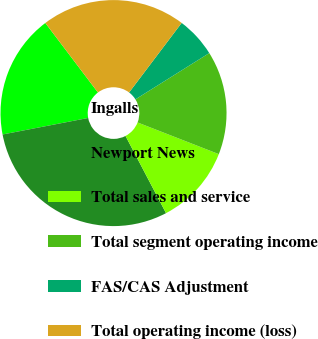Convert chart. <chart><loc_0><loc_0><loc_500><loc_500><pie_chart><fcel>Ingalls<fcel>Newport News<fcel>Total sales and service<fcel>Total segment operating income<fcel>FAS/CAS Adjustment<fcel>Total operating income (loss)<nl><fcel>17.72%<fcel>29.66%<fcel>11.39%<fcel>14.83%<fcel>5.79%<fcel>20.61%<nl></chart> 